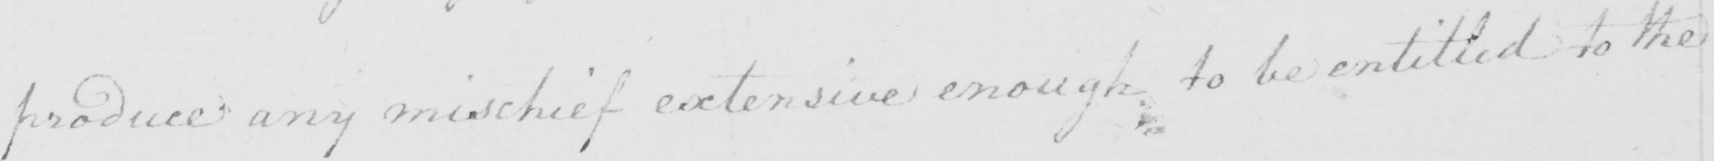Please provide the text content of this handwritten line. produce any mischief extensive enough to be entitled to the 